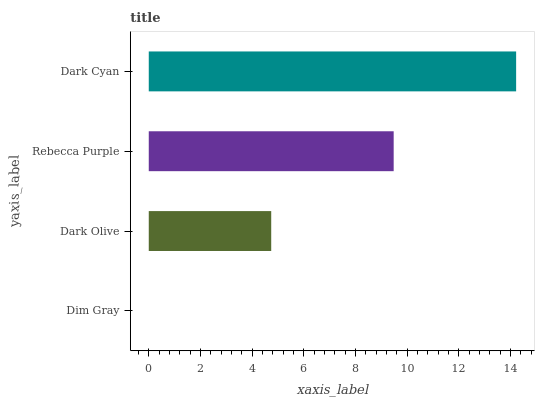Is Dim Gray the minimum?
Answer yes or no. Yes. Is Dark Cyan the maximum?
Answer yes or no. Yes. Is Dark Olive the minimum?
Answer yes or no. No. Is Dark Olive the maximum?
Answer yes or no. No. Is Dark Olive greater than Dim Gray?
Answer yes or no. Yes. Is Dim Gray less than Dark Olive?
Answer yes or no. Yes. Is Dim Gray greater than Dark Olive?
Answer yes or no. No. Is Dark Olive less than Dim Gray?
Answer yes or no. No. Is Rebecca Purple the high median?
Answer yes or no. Yes. Is Dark Olive the low median?
Answer yes or no. Yes. Is Dim Gray the high median?
Answer yes or no. No. Is Dim Gray the low median?
Answer yes or no. No. 